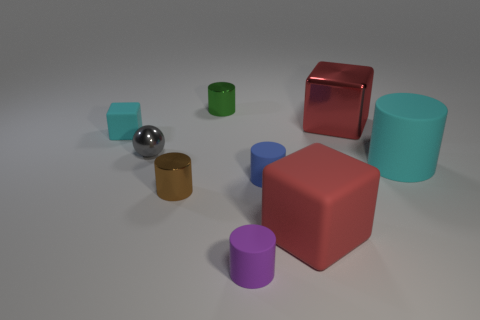Can you describe the textures of the objects in the image? Certainly! The objects exhibit a variety of textures. The large red cube and the small purple cylinder have a slightly reflective, glossy surface. The metal sphere appears highly polished and has a mirror-like finish, reflecting its surroundings. The wooden textured cylinder has a grainy, matte appearance indicative of wood, while the remaining cylinders and the large blue cube have a smooth matte texture, typical of painted plastic or synthetic materials. 